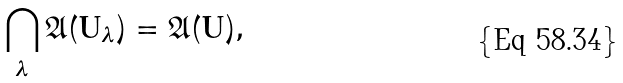Convert formula to latex. <formula><loc_0><loc_0><loc_500><loc_500>\bigcap _ { \lambda } \mathfrak A ( \mathsf U _ { \lambda } ) = \mathfrak A ( \mathsf U ) ,</formula> 